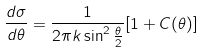<formula> <loc_0><loc_0><loc_500><loc_500>\frac { d \sigma } { d \theta } = \frac { 1 } { 2 \pi k \sin ^ { 2 } { \frac { \theta } { 2 } } } [ 1 + C ( \theta ) ]</formula> 